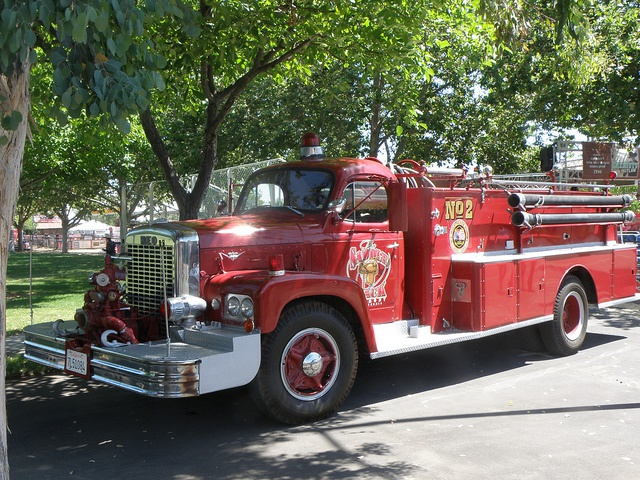Describe the objects in this image and their specific colors. I can see a truck in black, maroon, gray, and salmon tones in this image. 